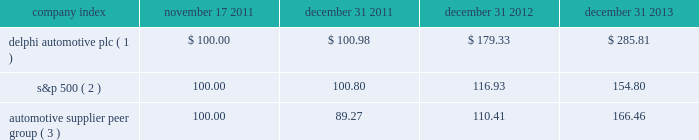Stock performance graph * $ 100 invested on 11/17/11 in our stock or 10/31/11 in the relevant index , including reinvestment of dividends .
Fiscal year ending december 31 , 2013 .
( 1 ) delphi automotive plc ( 2 ) s&p 500 2013 standard & poor 2019s 500 total return index ( 3 ) automotive supplier peer group 2013 russell 3000 auto parts index , including american axle & manufacturing , borgwarner inc. , cooper tire & rubber company , dana holding corp. , delphi automotive plc , dorman products inc. , federal-mogul corp. , ford motor co. , fuel systems solutions inc. , general motors co. , gentex corp. , gentherm inc. , genuine parts co. , johnson controls inc. , lkq corp. , lear corp. , meritor inc. , remy international inc. , standard motor products inc. , stoneridge inc. , superior industries international , trw automotive holdings corp. , tenneco inc. , tesla motors inc. , the goodyear tire & rubber co. , tower international inc. , visteon corp. , and wabco holdings inc .
Company index november 17 , december 31 , december 31 , december 31 .
Dividends on february 26 , 2013 , the board of directors approved the initiation of dividend payments on the company's ordinary shares .
The board of directors declared a regular quarterly cash dividend of $ 0.17 per ordinary share that was paid in each quarter of 2013 .
In addition , in january 2014 , the board of directors declared a regular quarterly cash dividend of $ 0.25 per ordinary share , payable on february 27 , 2014 to shareholders of record at the close of business on february 18 , 2014 .
In october 2011 , the board of managers of delphi automotive llp approved a distribution of approximately $ 95 million , which was paid on december 5 , 2011 , principally in respect of taxes , to members of delphi automotive llp who held membership interests as of the close of business on october 31 , 2011. .
What was the percentage total return for delphi automotive plc for the three years ended december 31 2013?\\n? 
Computations: ((285.81 - 100) / 100)
Answer: 1.8581. 